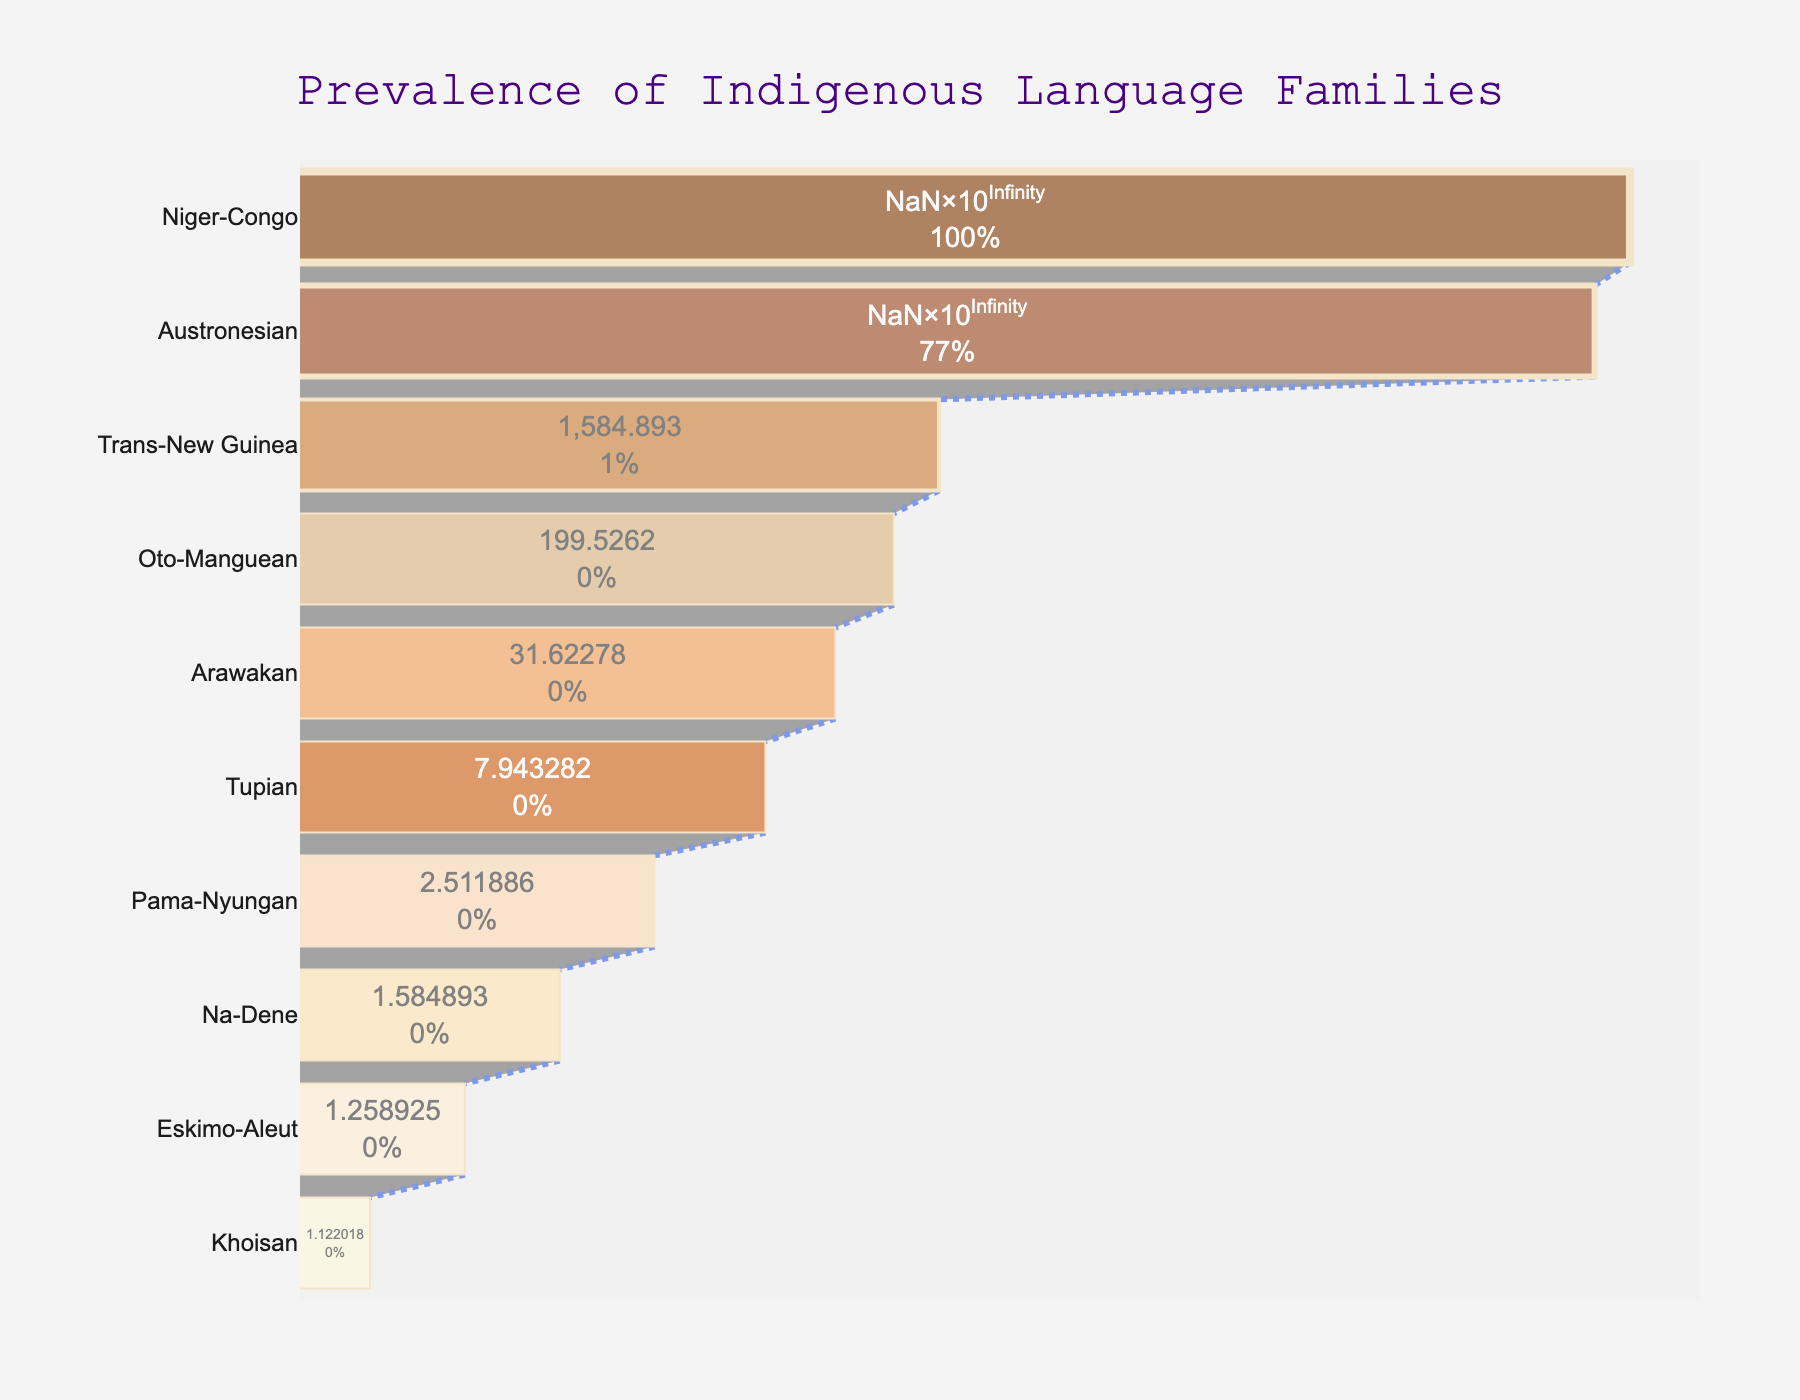what is the title of the funnel chart? The title is positioned at the top center of the chart. It states the main focus of the figure.
Answer: Prevalence of Indigenous Language Families how many language families are represented in the chart? Count the number of different y-axis categories listed.
Answer: 10 which language family has the highest number of speakers? Look at the topmost section of the funnel chart, which represents the largest value.
Answer: Niger-Congo how many speakers does the Austronesian language family have? Locate "Austronesian" on the y-axis and refer to the corresponding x-axis value.
Answer: 386 million what is the total number of speakers for the bottom three language families combined? Add the number of speakers for Pama-Nyungan, Na-Dene, and Eskimo-Aleut. 0.4 + 0.2 + 0.1 = 0.7 million
Answer: 0.7 million how does the number of speakers for the Arawakan family compare to the Tupian family? Compare the values in the funnel chart for both language families. 1.5 million for Arawakan vs 0.9 million for Tupian.
Answer: Arawakan has more speakers what proportion of total speakers does the Trans-New Guinea family constitute relative to the Niger-Congo family? Calculate the proportion by dividing the number of speakers of Trans-New Guinea by Niger-Congo and then comparing. 3.2 / 500 * 100%
Answer: 0.64% which colors are used to represent the language families in the chart? Describe the range of colors visible in the funnel chart's segments.
Answer: Shades of brown (chocolate, cinnamon, sandy brown, etc.) what is the percentage of speakers in the Oto-Manguean family relative to the initial value (Niger-Congo family)? Oto-Manguean has 2.3 million speakers. Divide by Niger-Congo's 500 million and multiply by 100 to get the percentage. 2.3 / 500 * 100 = 0.46%
Answer: 0.46% label the language family at each step from the top to the bottom of the chart Identify and list each language family in the order displayed in the funnel chart.
Answer: Niger-Congo, Austronesian, Trans-New Guinea, Oto-Manguean, Arawakan, Tupian, Pama-Nyungan, Na-Dene, Eskimo-Aleut, Khoisan 